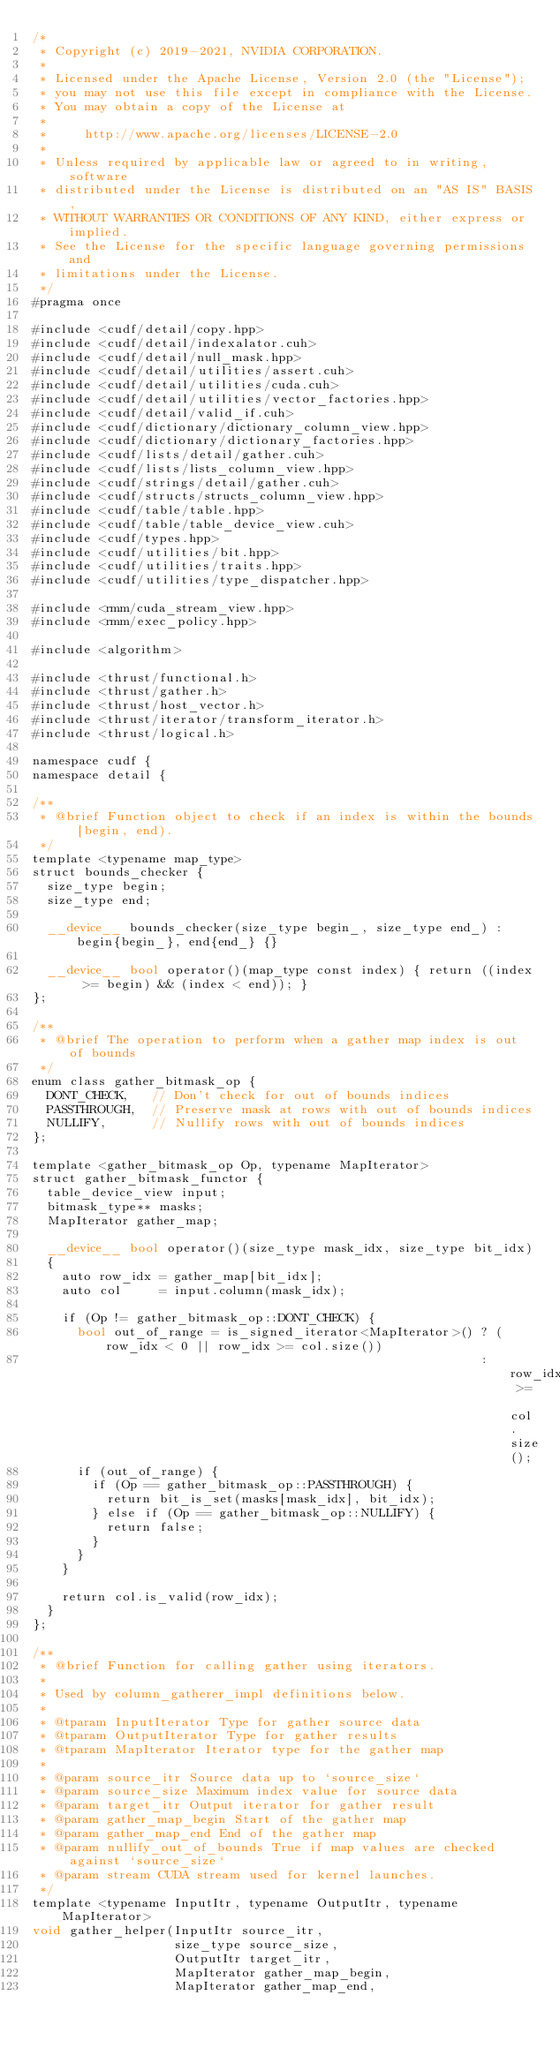Convert code to text. <code><loc_0><loc_0><loc_500><loc_500><_Cuda_>/*
 * Copyright (c) 2019-2021, NVIDIA CORPORATION.
 *
 * Licensed under the Apache License, Version 2.0 (the "License");
 * you may not use this file except in compliance with the License.
 * You may obtain a copy of the License at
 *
 *     http://www.apache.org/licenses/LICENSE-2.0
 *
 * Unless required by applicable law or agreed to in writing, software
 * distributed under the License is distributed on an "AS IS" BASIS,
 * WITHOUT WARRANTIES OR CONDITIONS OF ANY KIND, either express or implied.
 * See the License for the specific language governing permissions and
 * limitations under the License.
 */
#pragma once

#include <cudf/detail/copy.hpp>
#include <cudf/detail/indexalator.cuh>
#include <cudf/detail/null_mask.hpp>
#include <cudf/detail/utilities/assert.cuh>
#include <cudf/detail/utilities/cuda.cuh>
#include <cudf/detail/utilities/vector_factories.hpp>
#include <cudf/detail/valid_if.cuh>
#include <cudf/dictionary/dictionary_column_view.hpp>
#include <cudf/dictionary/dictionary_factories.hpp>
#include <cudf/lists/detail/gather.cuh>
#include <cudf/lists/lists_column_view.hpp>
#include <cudf/strings/detail/gather.cuh>
#include <cudf/structs/structs_column_view.hpp>
#include <cudf/table/table.hpp>
#include <cudf/table/table_device_view.cuh>
#include <cudf/types.hpp>
#include <cudf/utilities/bit.hpp>
#include <cudf/utilities/traits.hpp>
#include <cudf/utilities/type_dispatcher.hpp>

#include <rmm/cuda_stream_view.hpp>
#include <rmm/exec_policy.hpp>

#include <algorithm>

#include <thrust/functional.h>
#include <thrust/gather.h>
#include <thrust/host_vector.h>
#include <thrust/iterator/transform_iterator.h>
#include <thrust/logical.h>

namespace cudf {
namespace detail {

/**
 * @brief Function object to check if an index is within the bounds [begin, end).
 */
template <typename map_type>
struct bounds_checker {
  size_type begin;
  size_type end;

  __device__ bounds_checker(size_type begin_, size_type end_) : begin{begin_}, end{end_} {}

  __device__ bool operator()(map_type const index) { return ((index >= begin) && (index < end)); }
};

/**
 * @brief The operation to perform when a gather map index is out of bounds
 */
enum class gather_bitmask_op {
  DONT_CHECK,   // Don't check for out of bounds indices
  PASSTHROUGH,  // Preserve mask at rows with out of bounds indices
  NULLIFY,      // Nullify rows with out of bounds indices
};

template <gather_bitmask_op Op, typename MapIterator>
struct gather_bitmask_functor {
  table_device_view input;
  bitmask_type** masks;
  MapIterator gather_map;

  __device__ bool operator()(size_type mask_idx, size_type bit_idx)
  {
    auto row_idx = gather_map[bit_idx];
    auto col     = input.column(mask_idx);

    if (Op != gather_bitmask_op::DONT_CHECK) {
      bool out_of_range = is_signed_iterator<MapIterator>() ? (row_idx < 0 || row_idx >= col.size())
                                                            : row_idx >= col.size();
      if (out_of_range) {
        if (Op == gather_bitmask_op::PASSTHROUGH) {
          return bit_is_set(masks[mask_idx], bit_idx);
        } else if (Op == gather_bitmask_op::NULLIFY) {
          return false;
        }
      }
    }

    return col.is_valid(row_idx);
  }
};

/**
 * @brief Function for calling gather using iterators.
 *
 * Used by column_gatherer_impl definitions below.
 *
 * @tparam InputIterator Type for gather source data
 * @tparam OutputIterator Type for gather results
 * @tparam MapIterator Iterator type for the gather map
 *
 * @param source_itr Source data up to `source_size`
 * @param source_size Maximum index value for source data
 * @param target_itr Output iterator for gather result
 * @param gather_map_begin Start of the gather map
 * @param gather_map_end End of the gather map
 * @param nullify_out_of_bounds True if map values are checked against `source_size`
 * @param stream CUDA stream used for kernel launches.
 */
template <typename InputItr, typename OutputItr, typename MapIterator>
void gather_helper(InputItr source_itr,
                   size_type source_size,
                   OutputItr target_itr,
                   MapIterator gather_map_begin,
                   MapIterator gather_map_end,</code> 